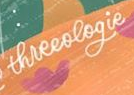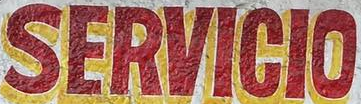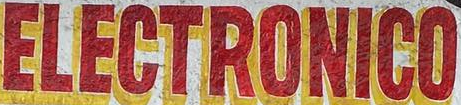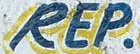What words can you see in these images in sequence, separated by a semicolon? threeologie; SERVICIO; ELECTRONICO; REP 